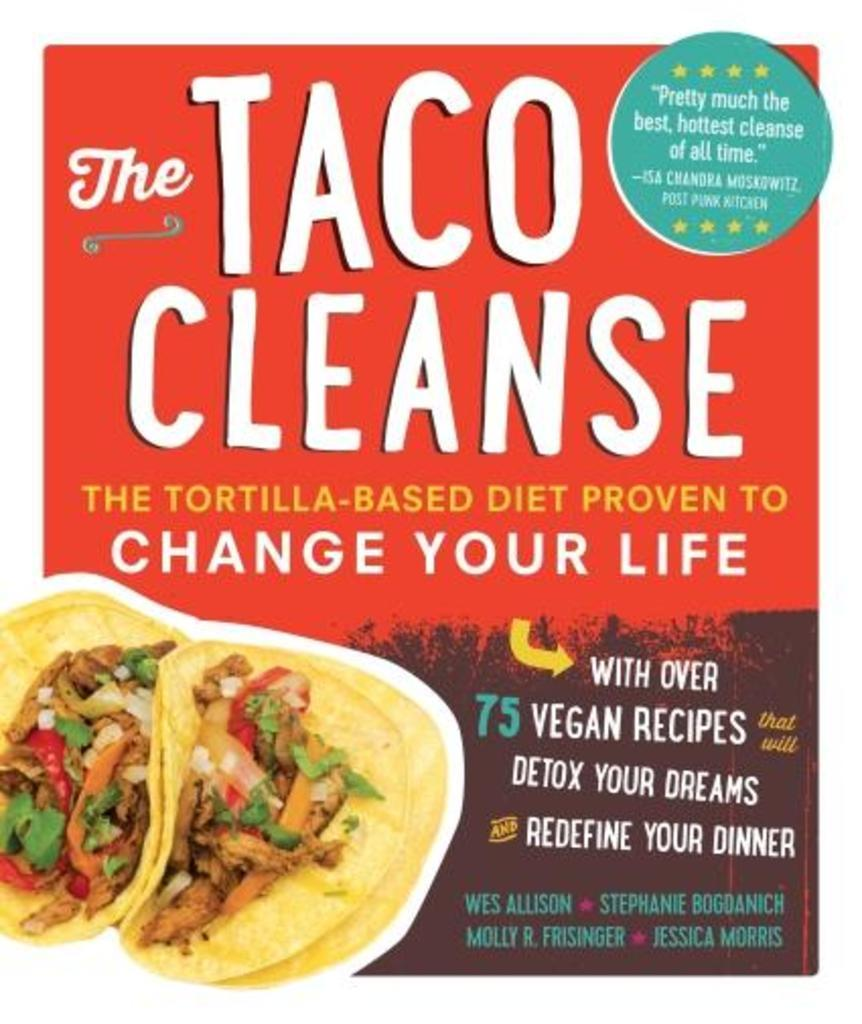What type of visual is the image in question? The image is a poster. What can be found on the poster besides text? There are images on the poster. What information is conveyed through the text on the poster? The text on the poster provides additional information or context. Can you tell me how many pigs are depicted on the poster? There is no pig present on the poster; it contains images and text as described in the facts. 